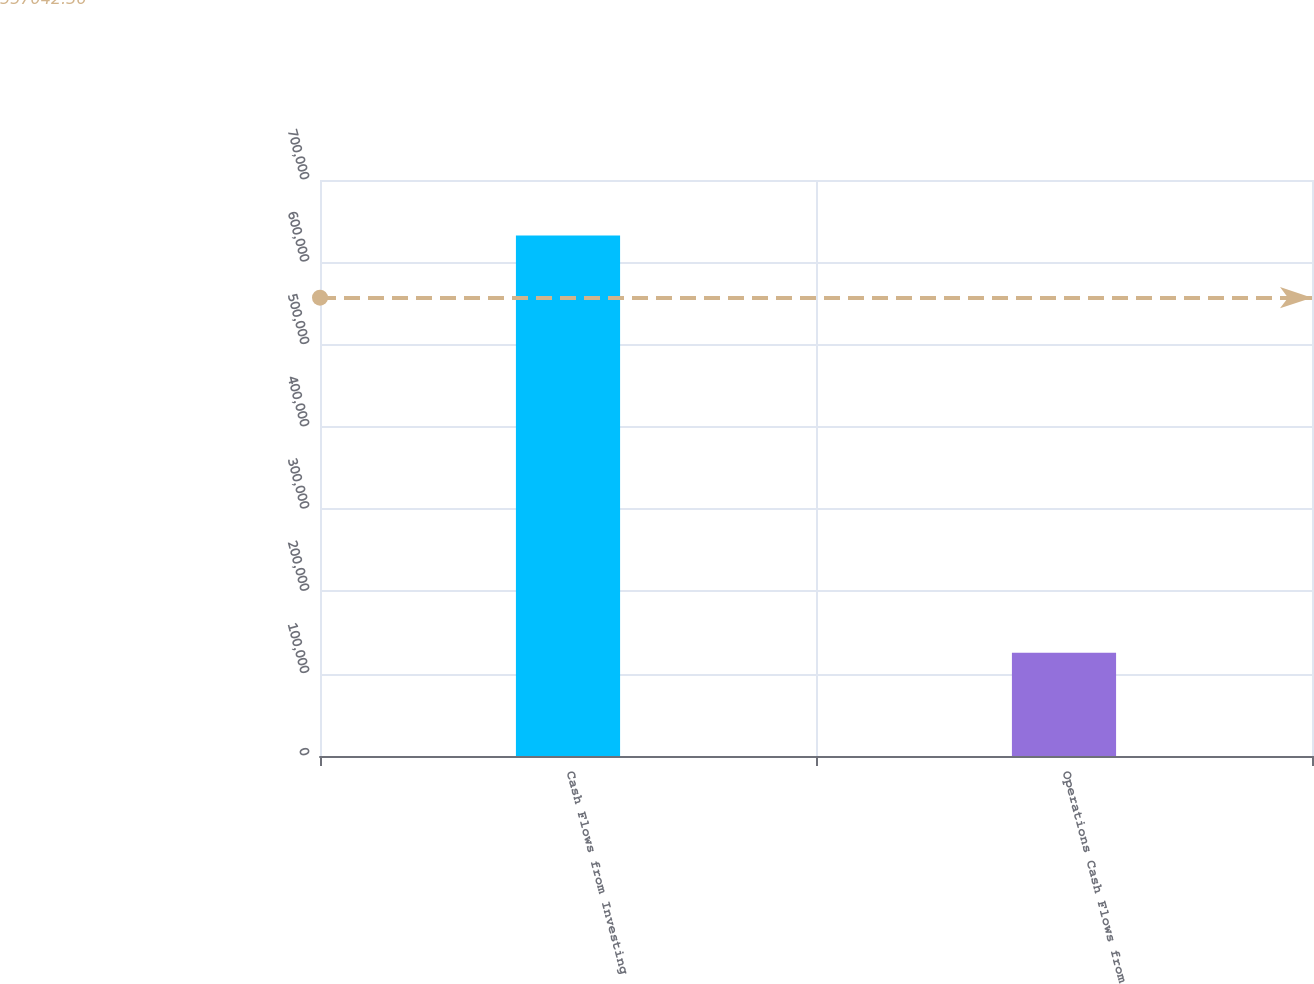Convert chart. <chart><loc_0><loc_0><loc_500><loc_500><bar_chart><fcel>Cash Flows from Investing<fcel>Operations Cash Flows from<nl><fcel>632703<fcel>125373<nl></chart> 